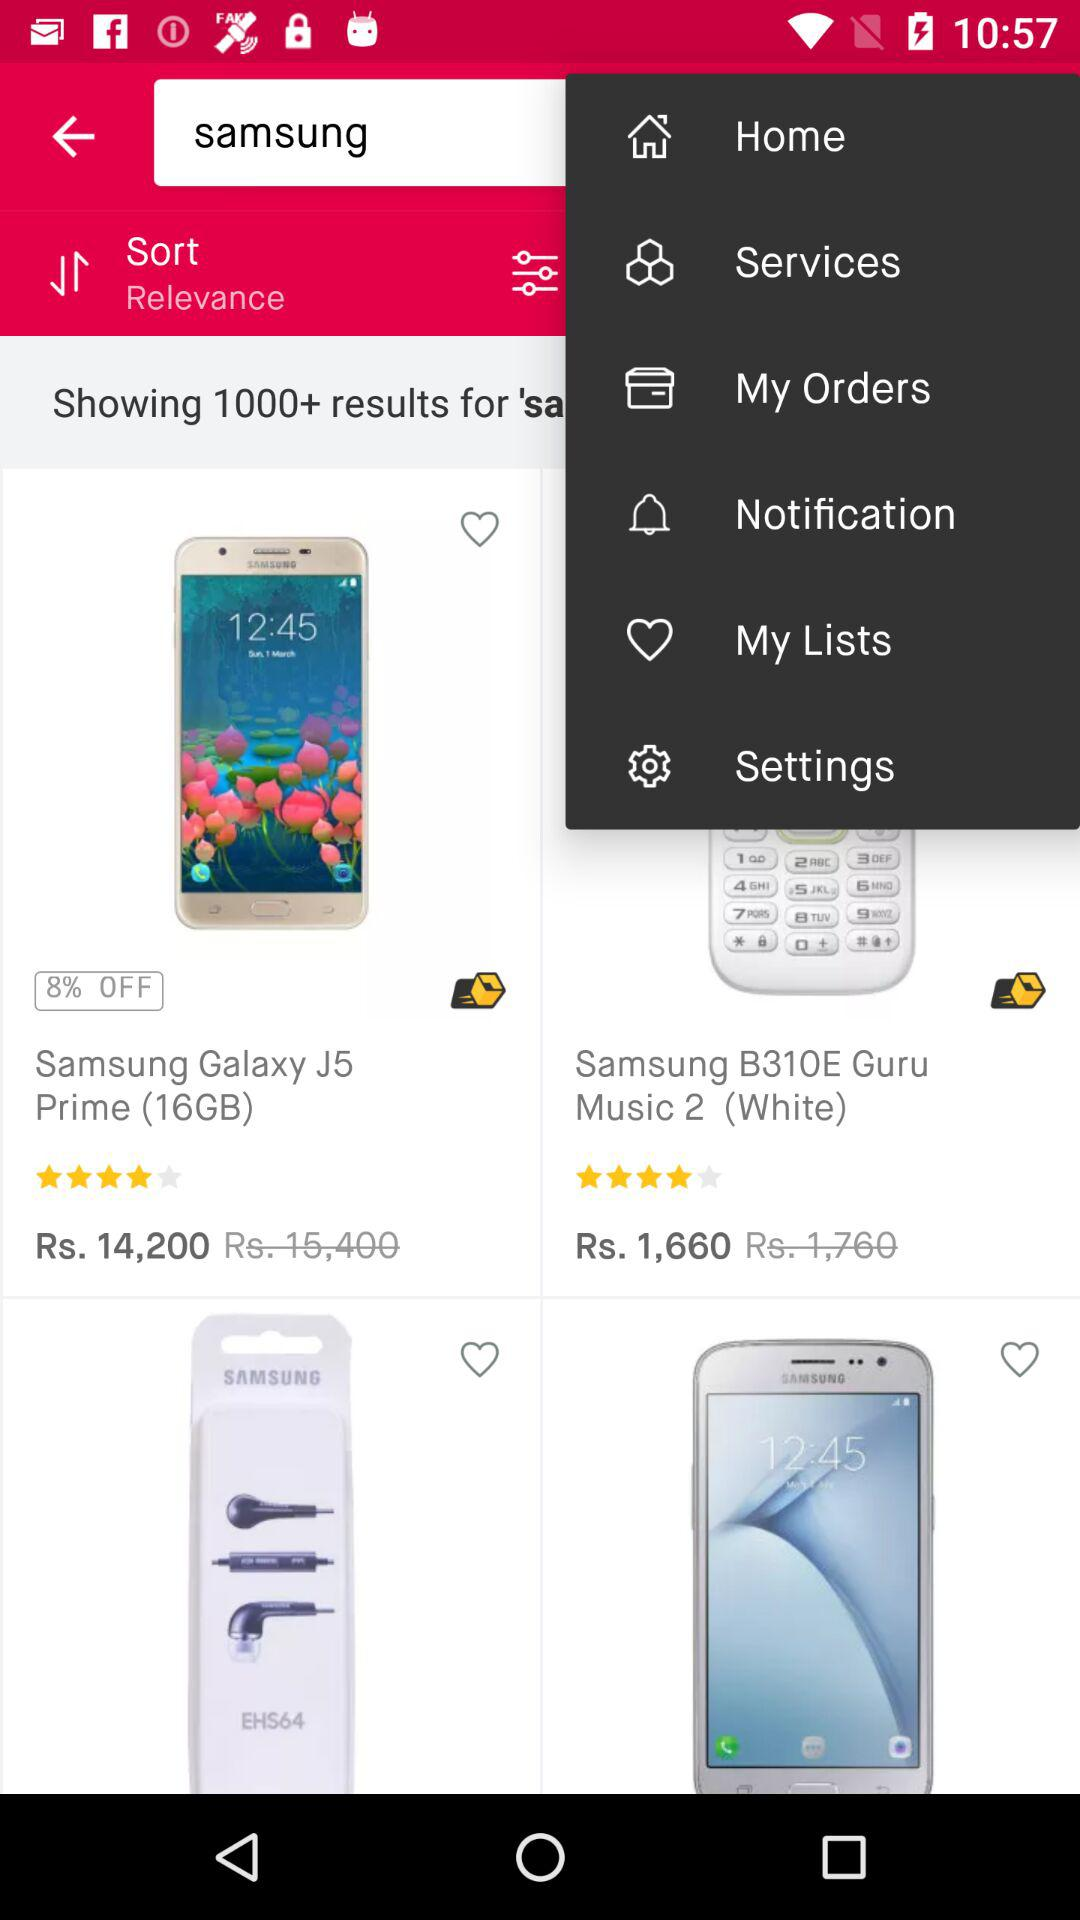What is the discounted price of the "Samsung B310E Guru Music 2 (White)"? The discounted price of the "Samsung B310E Guru Music 2 (White)" is Rs 1,660. 